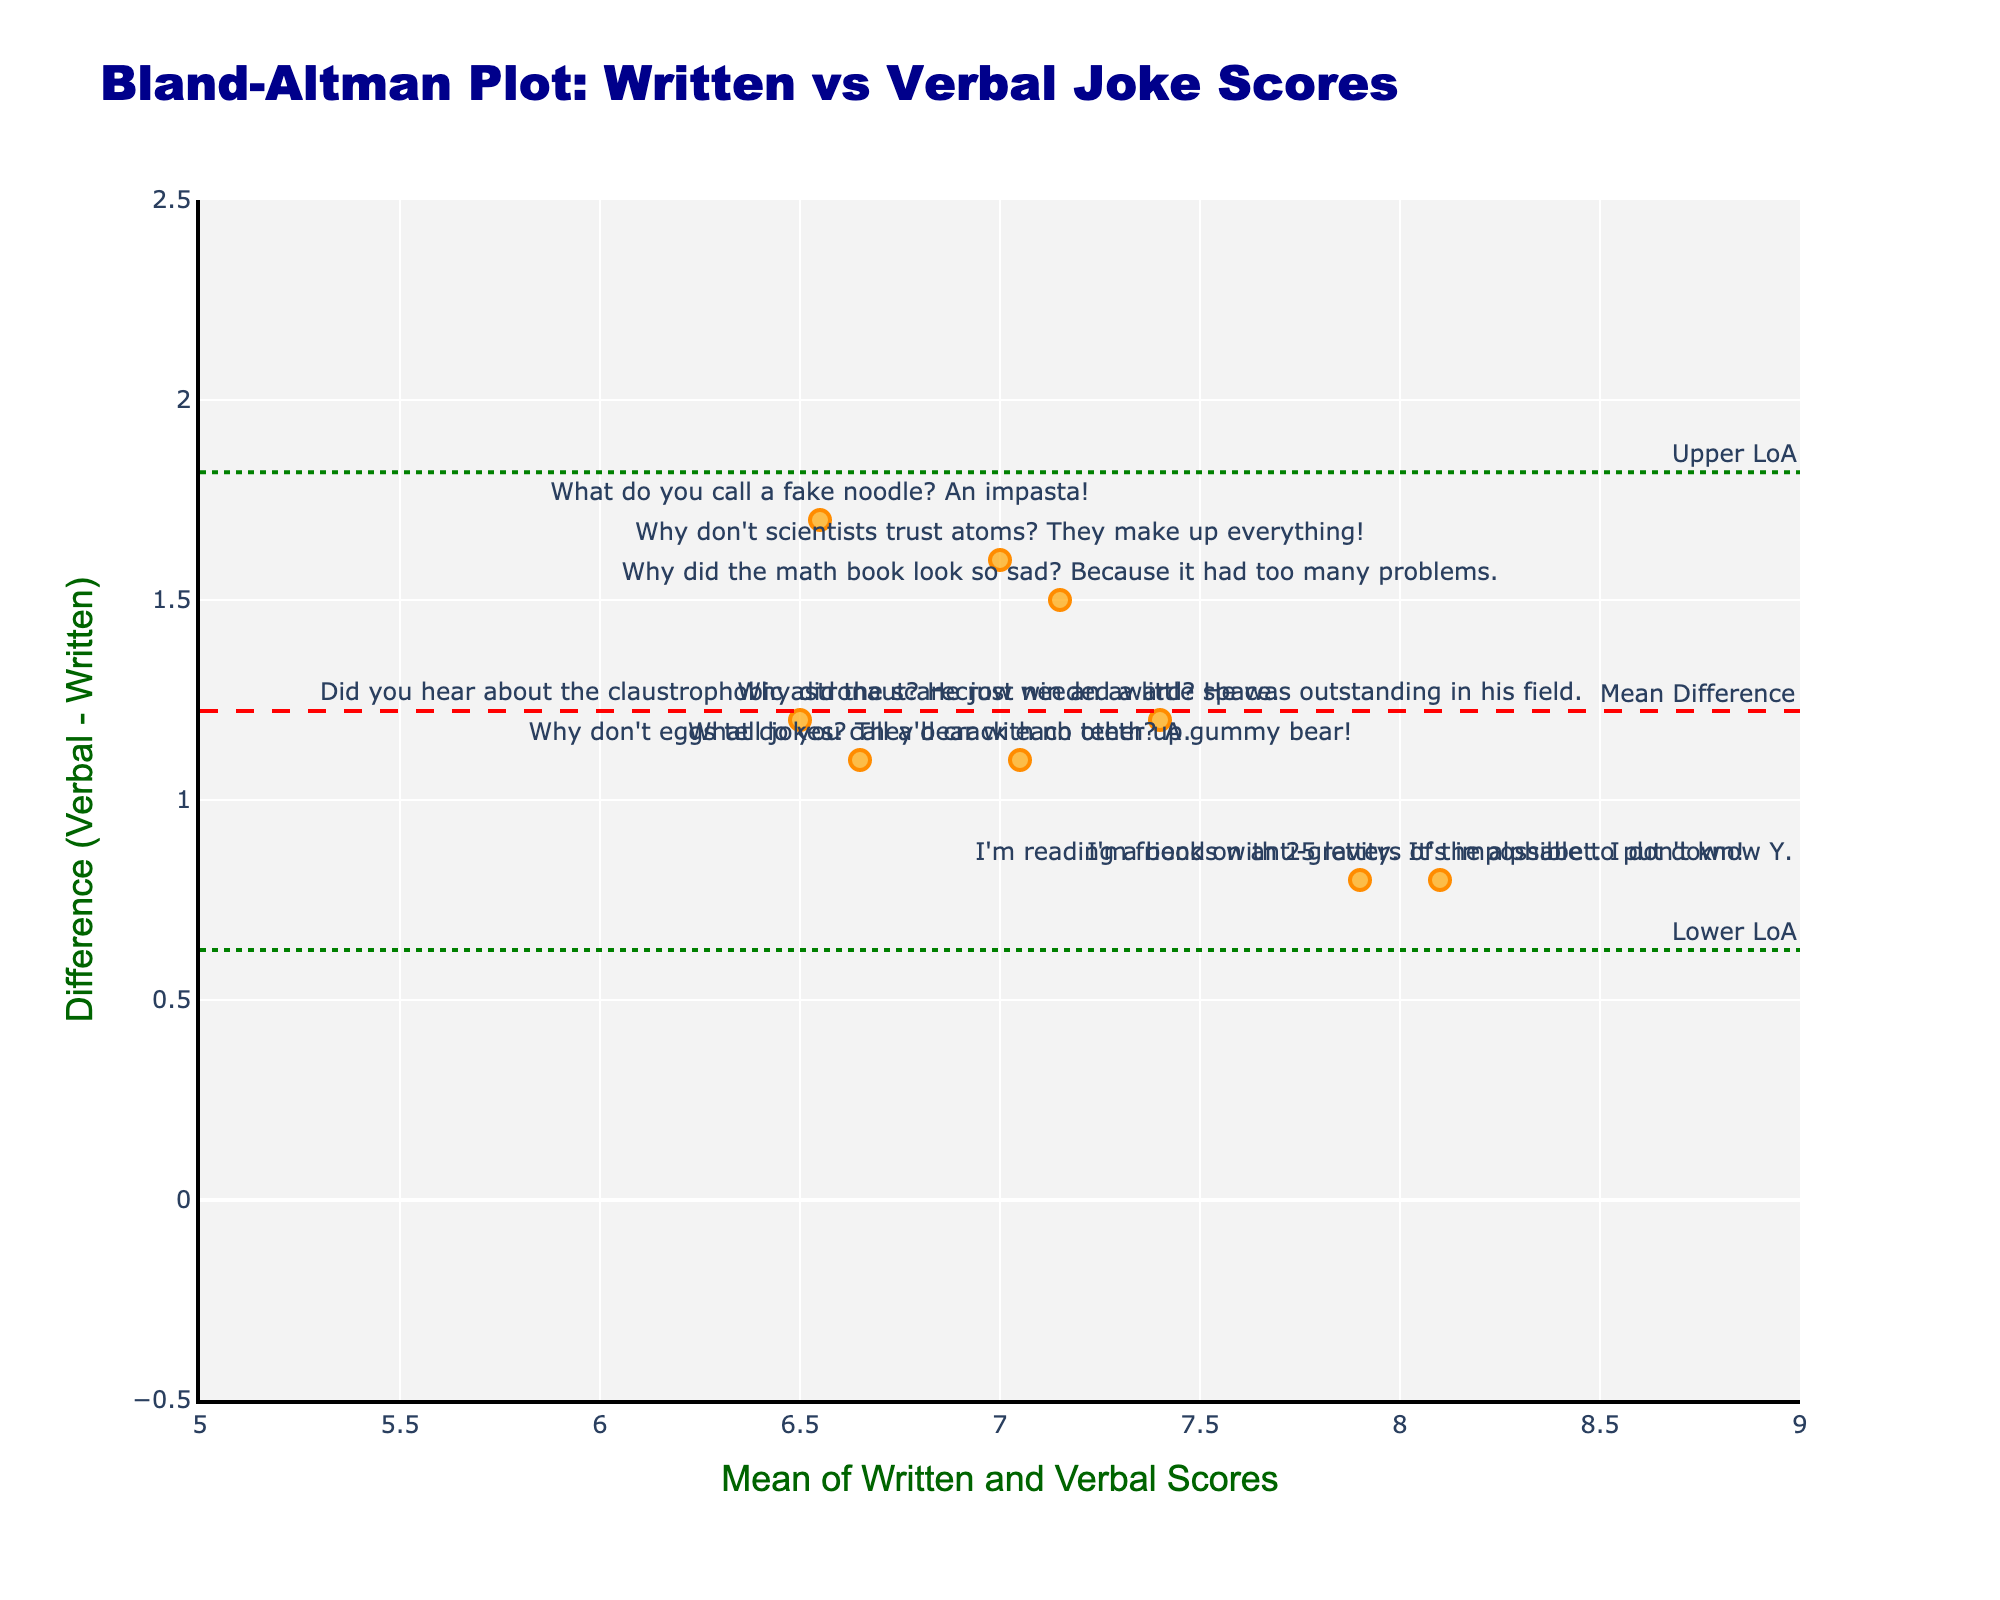How many jokes are plotted in the Bland-Altman plot? Count the data points in the plot labeled with joke texts. There are 9 jokes.
Answer: 9 What is the title of the plot? Read the title text displayed at the top of the plot. The title is "Bland-Altman Plot: Written vs Verbal Joke Scores".
Answer: Bland-Altman Plot: Written vs Verbal Joke Scores What do the horizontal lines in the plot represent? Identify the horizontal lines by hovering over them or reading their annotations. The dashed red line is the Mean Difference, and the dotted green lines are the Upper LoA and Lower LoA.
Answer: The Mean Difference, Upper LoA, and Lower LoA Which joke has the largest positive difference between Verbal and Written Scores? Look for the point with the highest y-value (difference) among the data points and read its label. The joke "What do you call a fake noodle? An impasta!" has the largest positive difference.
Answer: What do you call a fake noodle? An impasta! What is the mean difference between Verbal and Written Scores? Identify the horizontal dashed red line and read its annotation or hover over it to find the Mean Difference. The Mean Difference is annotated on the horizontal dashed red line.
Answer: Annotated on the dashed red line What is the value of the Upper LoA? Identify the upper dotted green line and read its annotation or hover over it to find the Upper LoA value. The Upper LoA value is 1.96 * std_diff above the Mean Difference.
Answer: Annotated above the mean difference Which joke has the smallest mean score between Written and Verbal Scores? Calculate the mean for each joke, then find and compare them to identify the smallest one. "What do you call a fake noodle? An impasta!" has the smallest mean score.
Answer: What do you call a fake noodle? An impasta! What range is selected for the x-axis? Read the numeric range displayed on the x-axis, which represents the mean of Written and Verbal Scores. The range for the x-axis is from 5 to 9.
Answer: From 5 to 9 Are verbal scores generally higher or lower than written scores? Observe the y-values (differences). If most points are above zero, then Verbal Scores are generally higher; if below, then lower. Most points are above zero, indicating higher Verbal Scores.
Answer: Higher Which joke has the least variation between Written and Verbal Scores? Find the point closest to the horizontal axis (difference of zero) by checking vertical proximity to the axis. "I'm reading a book on anti-gravity. It's impossible to put down!" has the least variation.
Answer: I'm reading a book on anti-gravity. It's impossible to put down! 